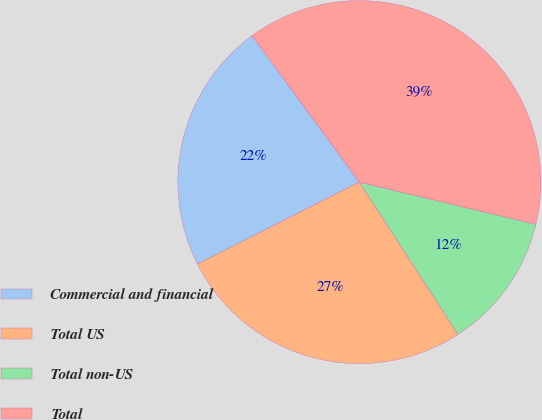Convert chart to OTSL. <chart><loc_0><loc_0><loc_500><loc_500><pie_chart><fcel>Commercial and financial<fcel>Total US<fcel>Total non-US<fcel>Total<nl><fcel>22.4%<fcel>26.68%<fcel>12.12%<fcel>38.8%<nl></chart> 